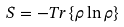Convert formula to latex. <formula><loc_0><loc_0><loc_500><loc_500>S = - T r \left \{ \rho \ln \rho \right \}</formula> 